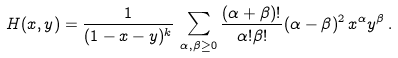Convert formula to latex. <formula><loc_0><loc_0><loc_500><loc_500>H ( x , y ) = \frac { 1 } { ( 1 - x - y ) ^ { k } } \, \sum _ { \alpha , \beta \geq 0 } \frac { ( \alpha + \beta ) ! } { \alpha ! \beta ! } ( \alpha - \beta ) ^ { 2 } \, x ^ { \alpha } y ^ { \beta } \, .</formula> 